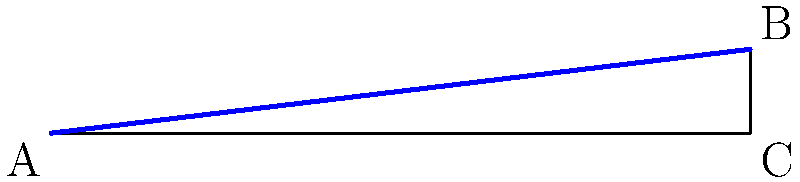As part of a public building renovation project, you're tasked with designing an accessible ramp. The ramp needs to rise 1.2 meters over a horizontal distance of 10 meters. What is the angle of slope for this ramp in degrees? To find the angle of slope, we can use basic trigonometry. Let's approach this step-by-step:

1) We have a right triangle where:
   - The base (adjacent side) is 10 meters
   - The height (opposite side) is 1.2 meters
   - We need to find the angle at the base

2) In this case, we can use the tangent function:

   $\tan(\theta) = \frac{\text{opposite}}{\text{adjacent}} = \frac{\text{rise}}{\text{run}}$

3) Plugging in our values:

   $\tan(\theta) = \frac{1.2}{10} = 0.12$

4) To find the angle, we need to use the inverse tangent (arctan) function:

   $\theta = \arctan(0.12)$

5) Using a calculator or math library:

   $\theta \approx 6.84^\circ$

6) Rounding to the nearest tenth of a degree:

   $\theta \approx 6.8^\circ$

This angle meets the Americans with Disabilities Act (ADA) guidelines, which specify that the maximum slope for a ramp should be 1:12 (which is equivalent to 4.8°). Our ramp with a 6.8° slope is slightly steeper but still within acceptable limits for many building codes.
Answer: $6.8^\circ$ 